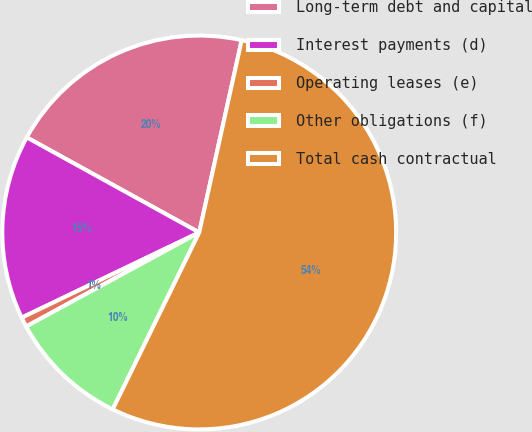Convert chart. <chart><loc_0><loc_0><loc_500><loc_500><pie_chart><fcel>Long-term debt and capital<fcel>Interest payments (d)<fcel>Operating leases (e)<fcel>Other obligations (f)<fcel>Total cash contractual<nl><fcel>20.44%<fcel>15.14%<fcel>0.8%<fcel>9.84%<fcel>53.78%<nl></chart> 